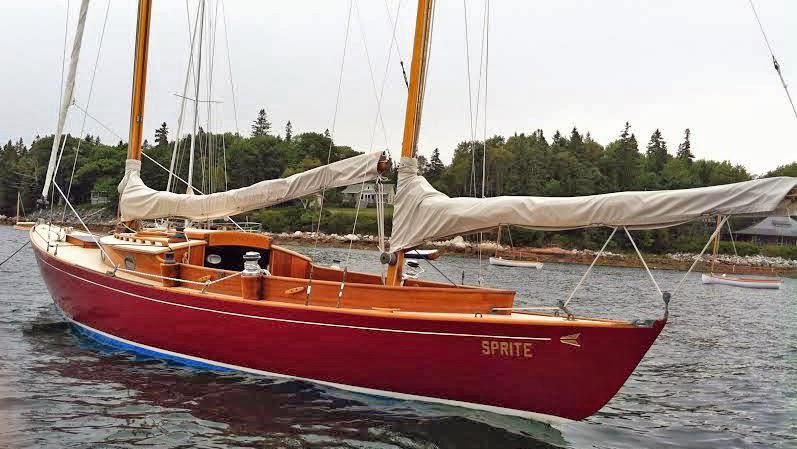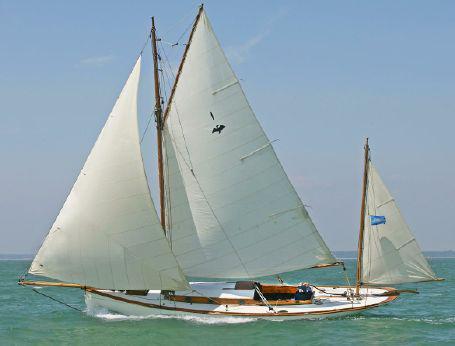The first image is the image on the left, the second image is the image on the right. For the images shown, is this caption "Both of the boats have all their sails up." true? Answer yes or no. No. The first image is the image on the left, the second image is the image on the right. Analyze the images presented: Is the assertion "The left and right image contains three sailboats with open sails." valid? Answer yes or no. No. 